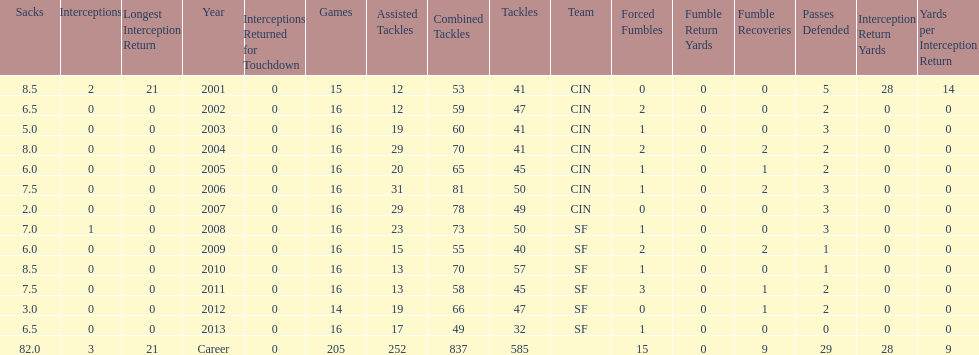How many years did he play where he did not recover a fumble? 7. Write the full table. {'header': ['Sacks', 'Interceptions', 'Longest Interception Return', 'Year', 'Interceptions Returned for Touchdown', 'Games', 'Assisted Tackles', 'Combined Tackles', 'Tackles', 'Team', 'Forced Fumbles', 'Fumble Return Yards', 'Fumble Recoveries', 'Passes Defended', 'Interception Return Yards', 'Yards per Interception Return'], 'rows': [['8.5', '2', '21', '2001', '0', '15', '12', '53', '41', 'CIN', '0', '0', '0', '5', '28', '14'], ['6.5', '0', '0', '2002', '0', '16', '12', '59', '47', 'CIN', '2', '0', '0', '2', '0', '0'], ['5.0', '0', '0', '2003', '0', '16', '19', '60', '41', 'CIN', '1', '0', '0', '3', '0', '0'], ['8.0', '0', '0', '2004', '0', '16', '29', '70', '41', 'CIN', '2', '0', '2', '2', '0', '0'], ['6.0', '0', '0', '2005', '0', '16', '20', '65', '45', 'CIN', '1', '0', '1', '2', '0', '0'], ['7.5', '0', '0', '2006', '0', '16', '31', '81', '50', 'CIN', '1', '0', '2', '3', '0', '0'], ['2.0', '0', '0', '2007', '0', '16', '29', '78', '49', 'CIN', '0', '0', '0', '3', '0', '0'], ['7.0', '1', '0', '2008', '0', '16', '23', '73', '50', 'SF', '1', '0', '0', '3', '0', '0'], ['6.0', '0', '0', '2009', '0', '16', '15', '55', '40', 'SF', '2', '0', '2', '1', '0', '0'], ['8.5', '0', '0', '2010', '0', '16', '13', '70', '57', 'SF', '1', '0', '0', '1', '0', '0'], ['7.5', '0', '0', '2011', '0', '16', '13', '58', '45', 'SF', '3', '0', '1', '2', '0', '0'], ['3.0', '0', '0', '2012', '0', '14', '19', '66', '47', 'SF', '0', '0', '1', '2', '0', '0'], ['6.5', '0', '0', '2013', '0', '16', '17', '49', '32', 'SF', '1', '0', '0', '0', '0', '0'], ['82.0', '3', '21', 'Career', '0', '205', '252', '837', '585', '', '15', '0', '9', '29', '28', '9']]} 